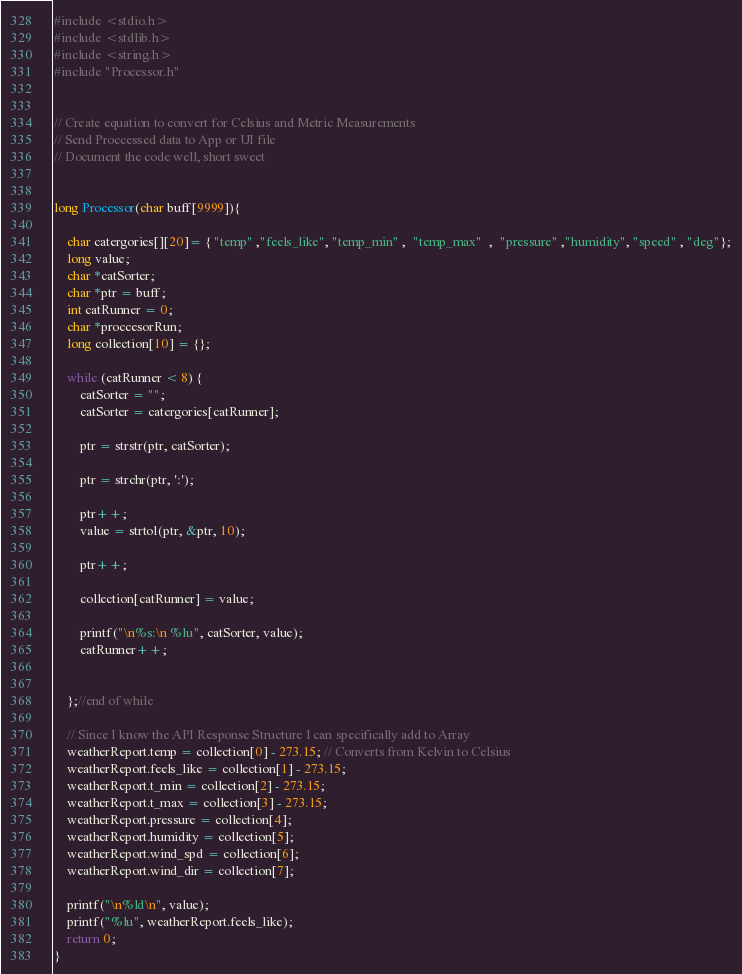<code> <loc_0><loc_0><loc_500><loc_500><_C_>#include <stdio.h>
#include <stdlib.h>
#include <string.h>
#include "Processor.h"


// Create equation to convert for Celsius and Metric Measurements
// Send Proccessed data to App or UI file
// Document the code well, short sweet


long Processor(char buff[9999]){
    
    char catergories[][20]= { "temp" ,"feels_like", "temp_min" ,  "temp_max"  ,  "pressure" ,"humidity", "speed" , "deg"};
    long value;
    char *catSorter;
    char *ptr = buff;
    int catRunner = 0;
    char *proccesorRun;
    long collection[10] = {};

    while (catRunner < 8) {
        catSorter = "";
        catSorter = catergories[catRunner];

        ptr = strstr(ptr, catSorter);
        
        ptr = strchr(ptr, ':');
        
        ptr++;
        value = strtol(ptr, &ptr, 10);
        
        ptr++;

        collection[catRunner] = value;

        printf("\n%s:\n %lu", catSorter, value);
        catRunner++;

        
    };//end of while

    // Since I know the API Response Structure I can specifically add to Array
    weatherReport.temp = collection[0] - 273.15; // Converts from Kelvin to Celsius
    weatherReport.feels_like = collection[1] - 273.15;
    weatherReport.t_min = collection[2] - 273.15;
    weatherReport.t_max = collection[3] - 273.15;
    weatherReport.pressure = collection[4];
    weatherReport.humidity = collection[5];
    weatherReport.wind_spd = collection[6];
    weatherReport.wind_dir = collection[7];

    printf("\n%ld\n", value);
    printf("%lu", weatherReport.feels_like);
    return 0;
}</code> 